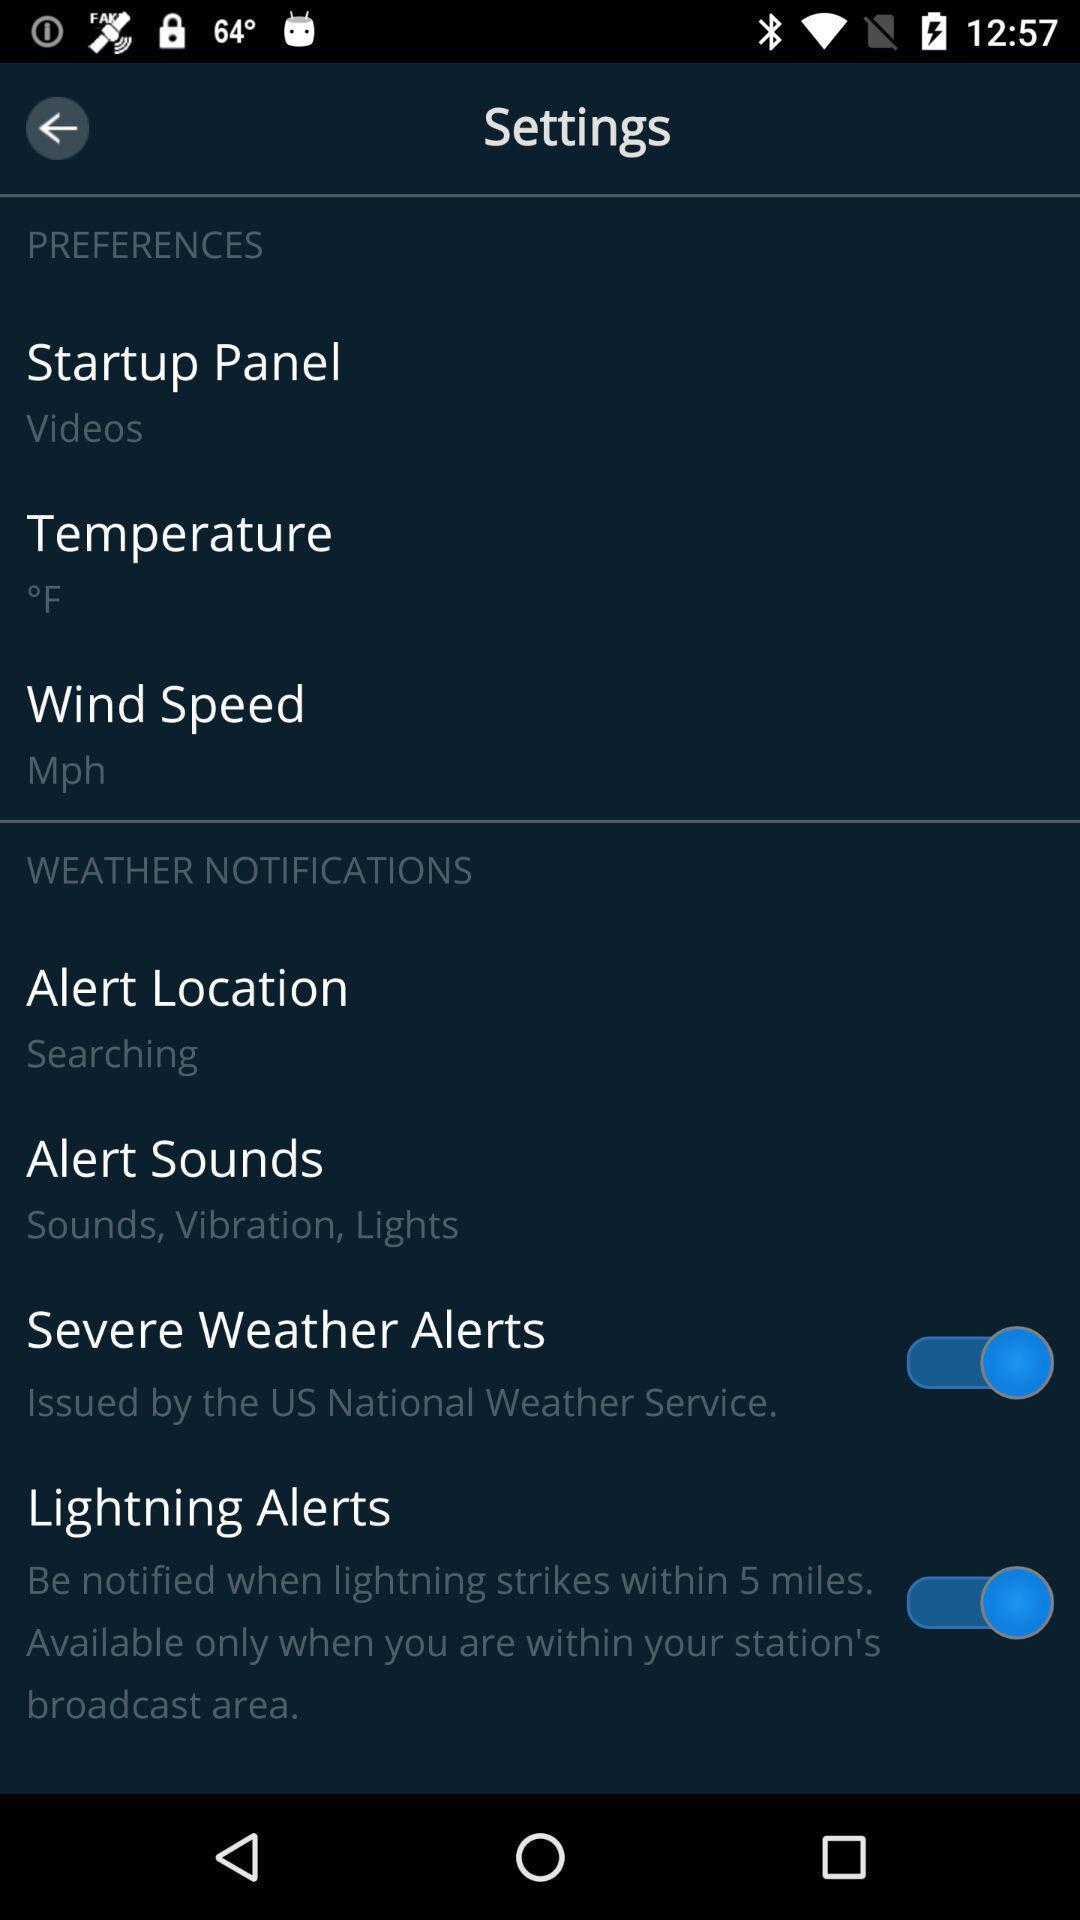Provide a textual representation of this image. Settings page. 